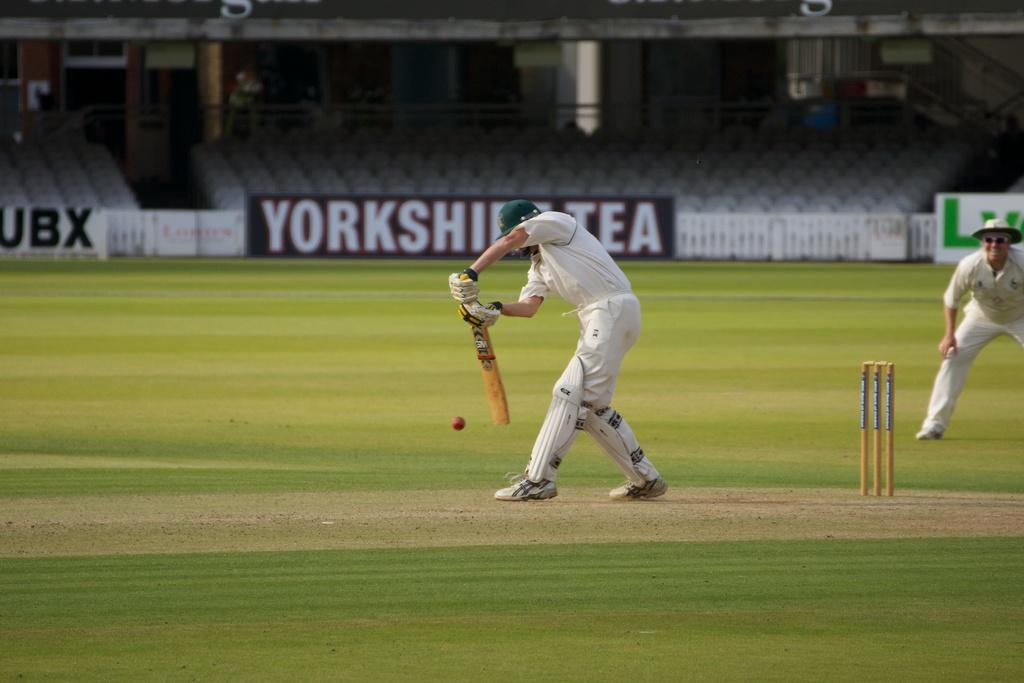What is the main subject of the image? The main subject of the image is a batsman. What is the batsman doing in the image? The batsman is batting. Who else is present in the image? There is a wicket keeper in the image. What is the wicket keeper doing? The wicket keeper is standing. What is the ground made of in the image? The ground is covered with grass. What can be seen in the background of the image? There is a sitting area in the background of the image. What type of board can be seen floating in the sea in the image? There is no board or sea present in the image; it features a batsman, a wicket keeper, and a grassy ground. 